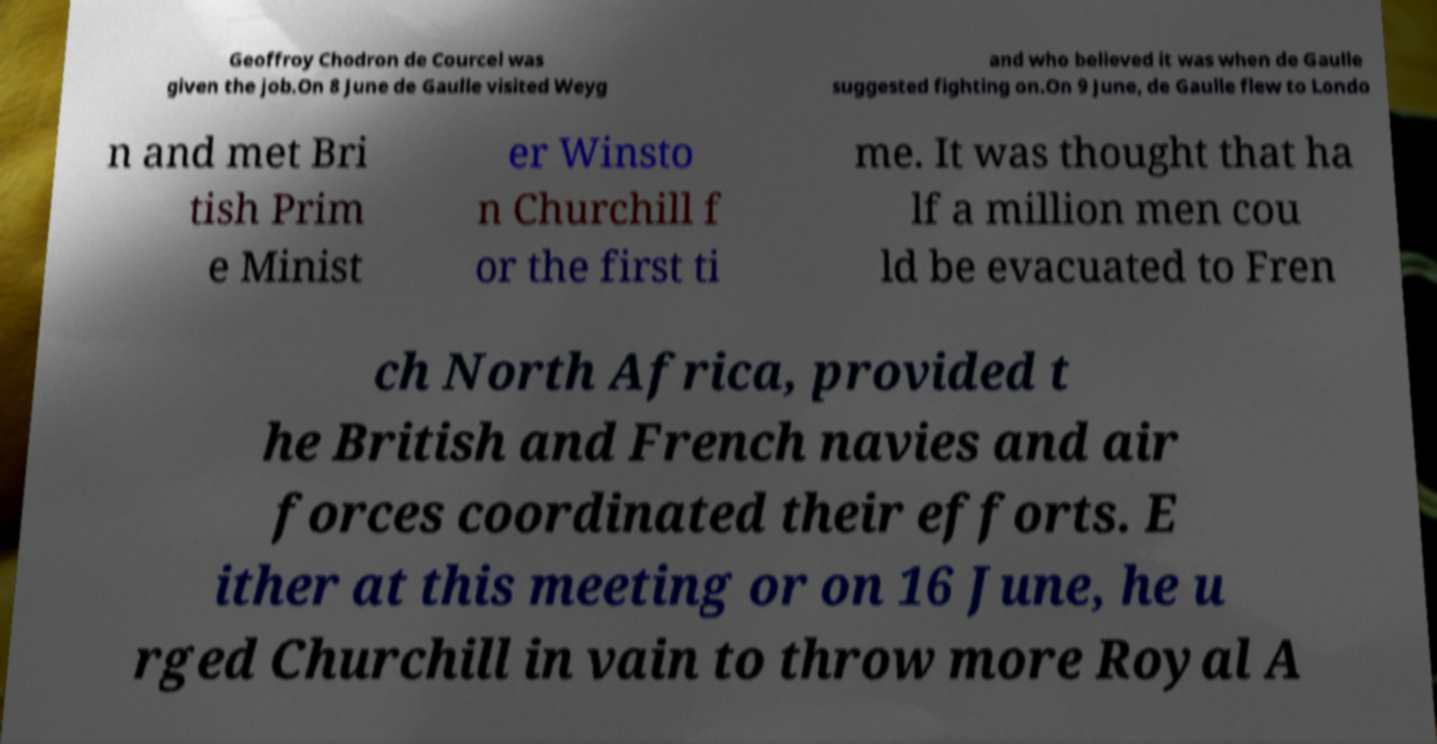Can you read and provide the text displayed in the image?This photo seems to have some interesting text. Can you extract and type it out for me? Geoffroy Chodron de Courcel was given the job.On 8 June de Gaulle visited Weyg and who believed it was when de Gaulle suggested fighting on.On 9 June, de Gaulle flew to Londo n and met Bri tish Prim e Minist er Winsto n Churchill f or the first ti me. It was thought that ha lf a million men cou ld be evacuated to Fren ch North Africa, provided t he British and French navies and air forces coordinated their efforts. E ither at this meeting or on 16 June, he u rged Churchill in vain to throw more Royal A 